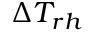<formula> <loc_0><loc_0><loc_500><loc_500>\Delta T _ { r h }</formula> 